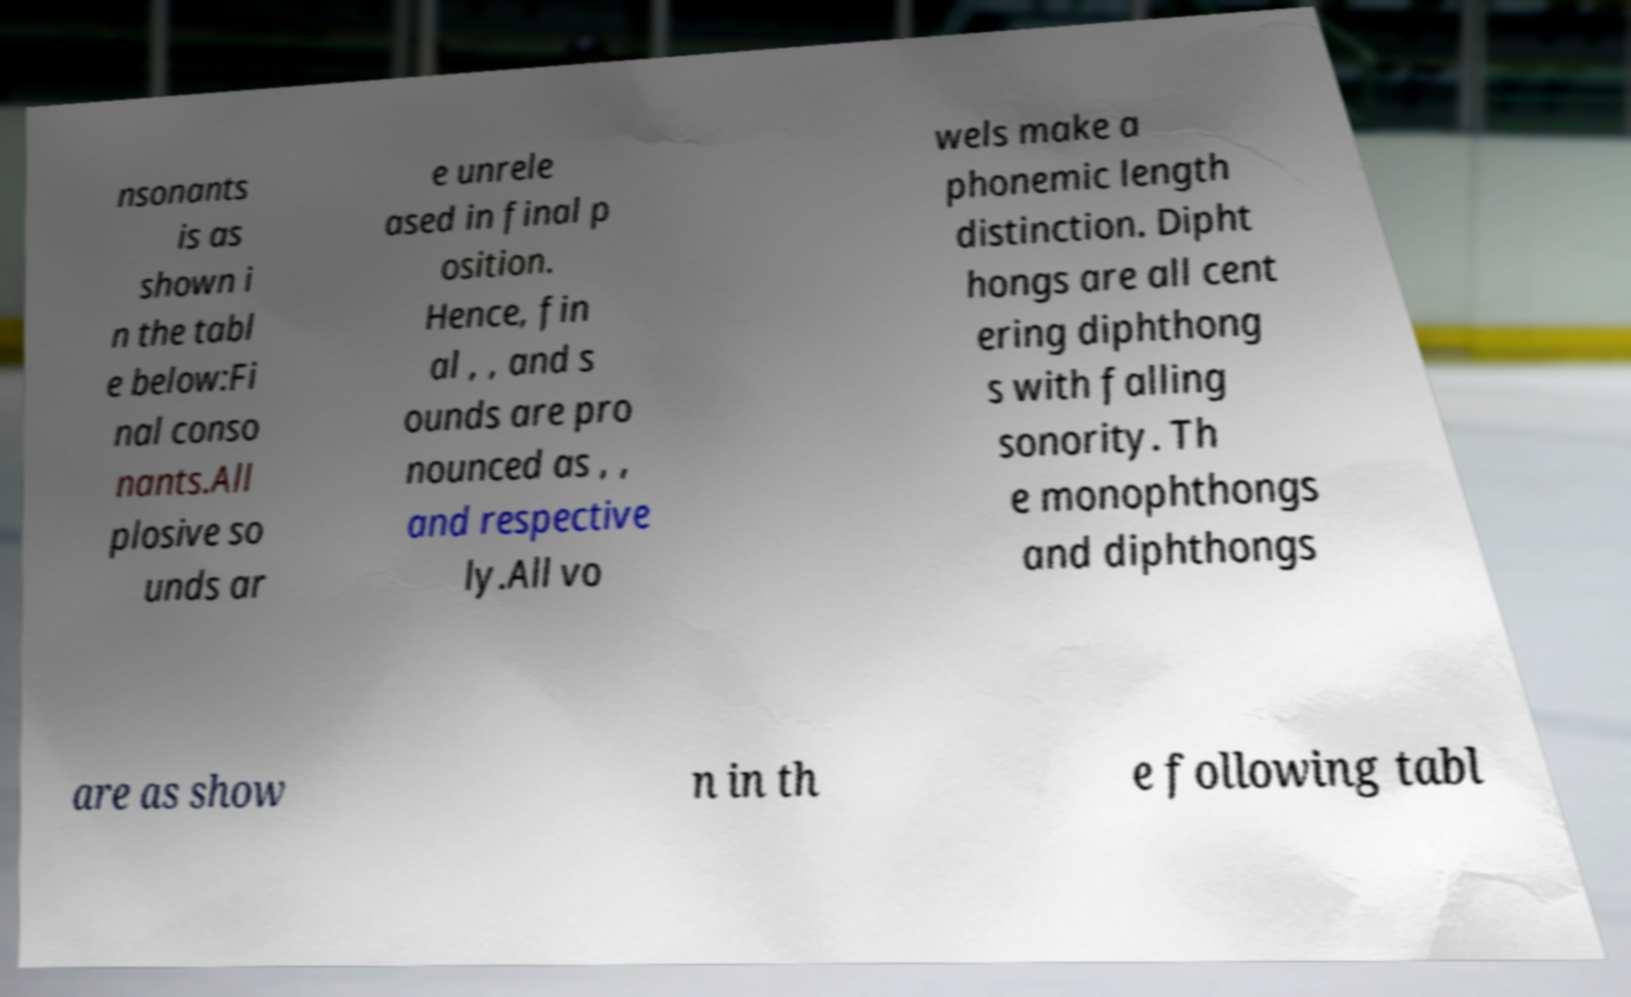Can you accurately transcribe the text from the provided image for me? nsonants is as shown i n the tabl e below:Fi nal conso nants.All plosive so unds ar e unrele ased in final p osition. Hence, fin al , , and s ounds are pro nounced as , , and respective ly.All vo wels make a phonemic length distinction. Dipht hongs are all cent ering diphthong s with falling sonority. Th e monophthongs and diphthongs are as show n in th e following tabl 